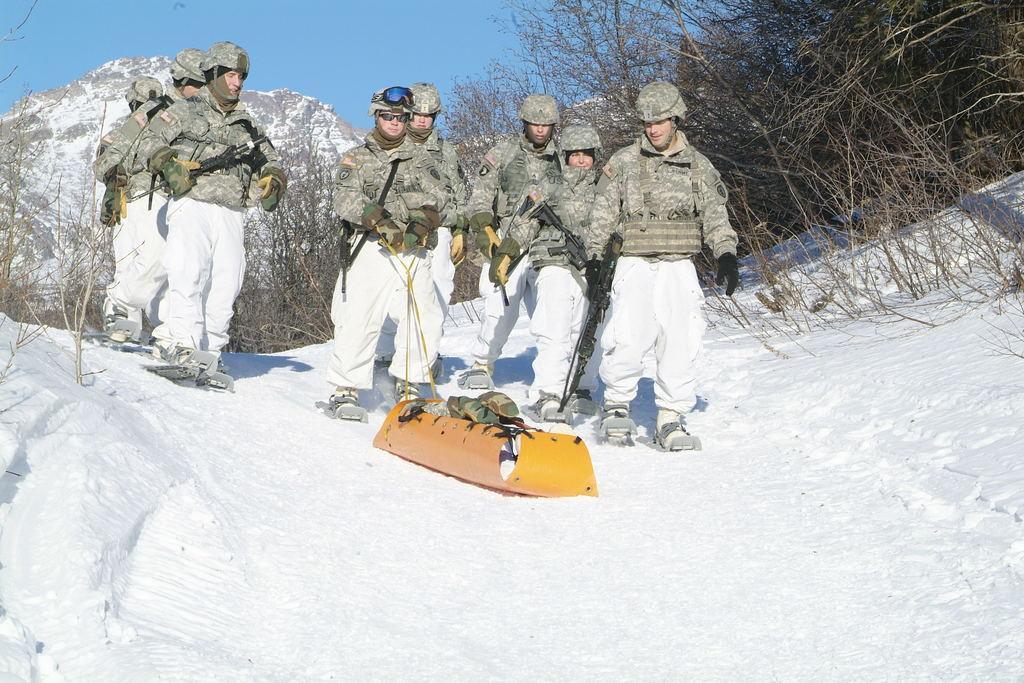Describe this image in one or two sentences. In this image there are group of soldiers, few of them are holding guns in there hands, in the middle there is a person he is holding an object, they are on a ice land, in the background there are plants, mountains and a blue sky. 